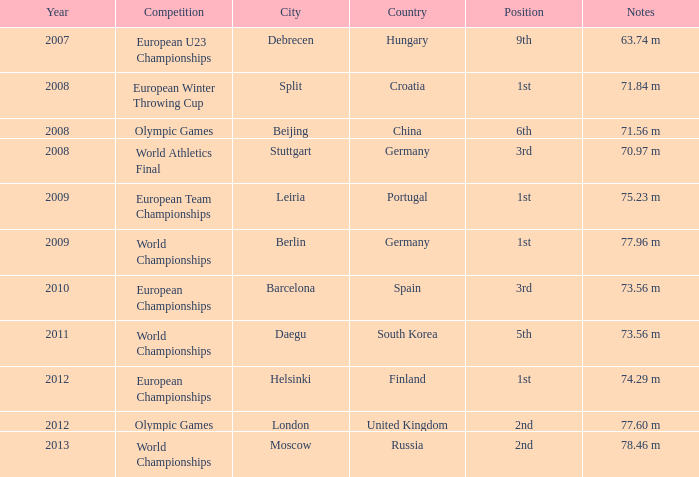Which year corresponds to the 9th rank? 2007.0. 